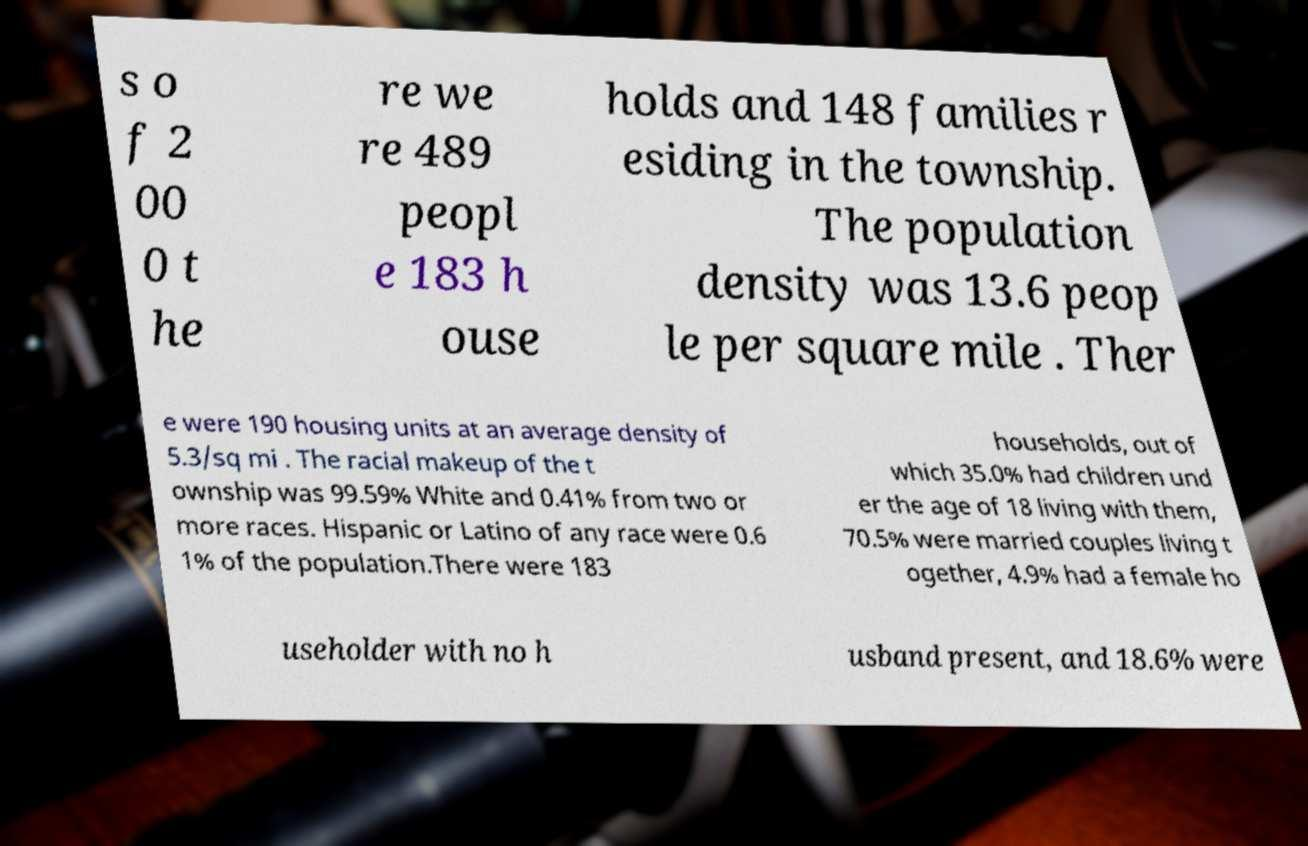For documentation purposes, I need the text within this image transcribed. Could you provide that? s o f 2 00 0 t he re we re 489 peopl e 183 h ouse holds and 148 families r esiding in the township. The population density was 13.6 peop le per square mile . Ther e were 190 housing units at an average density of 5.3/sq mi . The racial makeup of the t ownship was 99.59% White and 0.41% from two or more races. Hispanic or Latino of any race were 0.6 1% of the population.There were 183 households, out of which 35.0% had children und er the age of 18 living with them, 70.5% were married couples living t ogether, 4.9% had a female ho useholder with no h usband present, and 18.6% were 